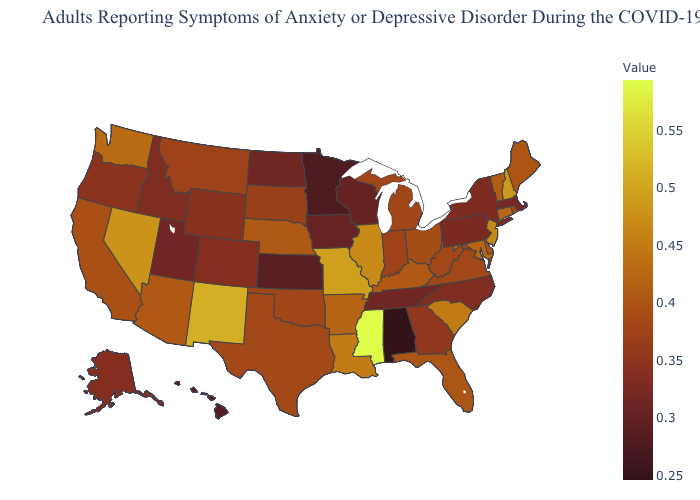Does Minnesota have the lowest value in the MidWest?
Be succinct. Yes. Does California have a higher value than Georgia?
Give a very brief answer. Yes. Which states hav the highest value in the Northeast?
Concise answer only. New Hampshire. Among the states that border Minnesota , which have the lowest value?
Give a very brief answer. Wisconsin. 